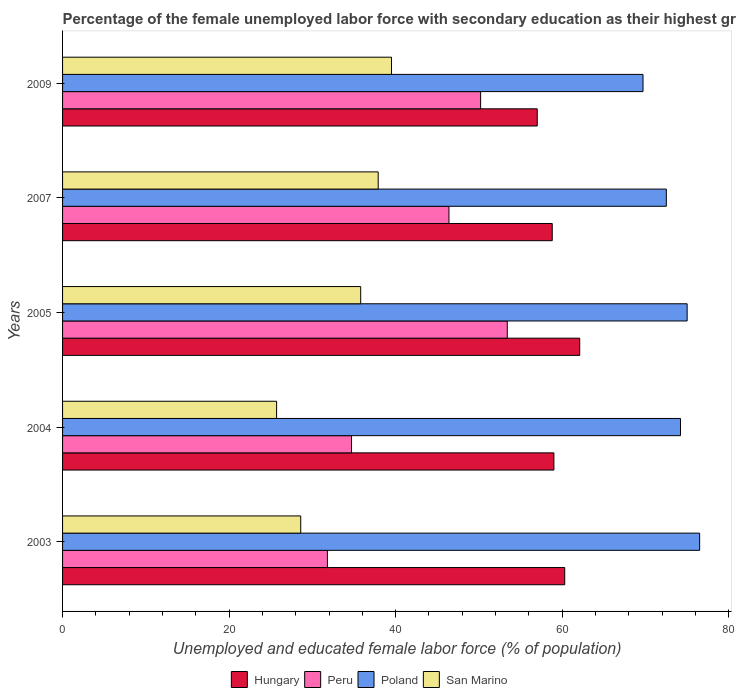How many bars are there on the 1st tick from the bottom?
Offer a terse response. 4. In how many cases, is the number of bars for a given year not equal to the number of legend labels?
Make the answer very short. 0. What is the percentage of the unemployed female labor force with secondary education in Poland in 2009?
Give a very brief answer. 69.7. Across all years, what is the maximum percentage of the unemployed female labor force with secondary education in Peru?
Provide a short and direct response. 53.4. Across all years, what is the minimum percentage of the unemployed female labor force with secondary education in Poland?
Give a very brief answer. 69.7. What is the total percentage of the unemployed female labor force with secondary education in San Marino in the graph?
Ensure brevity in your answer.  167.5. What is the difference between the percentage of the unemployed female labor force with secondary education in Poland in 2004 and that in 2005?
Offer a very short reply. -0.8. What is the difference between the percentage of the unemployed female labor force with secondary education in San Marino in 2004 and the percentage of the unemployed female labor force with secondary education in Peru in 2005?
Keep it short and to the point. -27.7. What is the average percentage of the unemployed female labor force with secondary education in Peru per year?
Your response must be concise. 43.3. In the year 2003, what is the difference between the percentage of the unemployed female labor force with secondary education in Hungary and percentage of the unemployed female labor force with secondary education in San Marino?
Your response must be concise. 31.7. What is the ratio of the percentage of the unemployed female labor force with secondary education in Poland in 2007 to that in 2009?
Provide a succinct answer. 1.04. Is the difference between the percentage of the unemployed female labor force with secondary education in Hungary in 2003 and 2007 greater than the difference between the percentage of the unemployed female labor force with secondary education in San Marino in 2003 and 2007?
Give a very brief answer. Yes. What is the difference between the highest and the second highest percentage of the unemployed female labor force with secondary education in Poland?
Offer a very short reply. 1.5. What is the difference between the highest and the lowest percentage of the unemployed female labor force with secondary education in Peru?
Give a very brief answer. 21.6. In how many years, is the percentage of the unemployed female labor force with secondary education in Poland greater than the average percentage of the unemployed female labor force with secondary education in Poland taken over all years?
Keep it short and to the point. 3. Is it the case that in every year, the sum of the percentage of the unemployed female labor force with secondary education in Peru and percentage of the unemployed female labor force with secondary education in San Marino is greater than the sum of percentage of the unemployed female labor force with secondary education in Poland and percentage of the unemployed female labor force with secondary education in Hungary?
Provide a succinct answer. No. What does the 4th bar from the top in 2007 represents?
Keep it short and to the point. Hungary. Is it the case that in every year, the sum of the percentage of the unemployed female labor force with secondary education in Peru and percentage of the unemployed female labor force with secondary education in San Marino is greater than the percentage of the unemployed female labor force with secondary education in Hungary?
Offer a terse response. Yes. How many bars are there?
Offer a terse response. 20. What is the difference between two consecutive major ticks on the X-axis?
Provide a succinct answer. 20. Does the graph contain grids?
Your answer should be very brief. No. How many legend labels are there?
Make the answer very short. 4. What is the title of the graph?
Your answer should be compact. Percentage of the female unemployed labor force with secondary education as their highest grade. Does "Tunisia" appear as one of the legend labels in the graph?
Keep it short and to the point. No. What is the label or title of the X-axis?
Make the answer very short. Unemployed and educated female labor force (% of population). What is the label or title of the Y-axis?
Give a very brief answer. Years. What is the Unemployed and educated female labor force (% of population) of Hungary in 2003?
Offer a terse response. 60.3. What is the Unemployed and educated female labor force (% of population) in Peru in 2003?
Your response must be concise. 31.8. What is the Unemployed and educated female labor force (% of population) in Poland in 2003?
Give a very brief answer. 76.5. What is the Unemployed and educated female labor force (% of population) of San Marino in 2003?
Offer a very short reply. 28.6. What is the Unemployed and educated female labor force (% of population) of Peru in 2004?
Offer a terse response. 34.7. What is the Unemployed and educated female labor force (% of population) of Poland in 2004?
Your answer should be compact. 74.2. What is the Unemployed and educated female labor force (% of population) in San Marino in 2004?
Offer a very short reply. 25.7. What is the Unemployed and educated female labor force (% of population) of Hungary in 2005?
Your answer should be compact. 62.1. What is the Unemployed and educated female labor force (% of population) in Peru in 2005?
Your answer should be compact. 53.4. What is the Unemployed and educated female labor force (% of population) in Poland in 2005?
Your response must be concise. 75. What is the Unemployed and educated female labor force (% of population) in San Marino in 2005?
Offer a terse response. 35.8. What is the Unemployed and educated female labor force (% of population) of Hungary in 2007?
Offer a very short reply. 58.8. What is the Unemployed and educated female labor force (% of population) of Peru in 2007?
Offer a very short reply. 46.4. What is the Unemployed and educated female labor force (% of population) of Poland in 2007?
Give a very brief answer. 72.5. What is the Unemployed and educated female labor force (% of population) in San Marino in 2007?
Give a very brief answer. 37.9. What is the Unemployed and educated female labor force (% of population) of Hungary in 2009?
Keep it short and to the point. 57. What is the Unemployed and educated female labor force (% of population) of Peru in 2009?
Ensure brevity in your answer.  50.2. What is the Unemployed and educated female labor force (% of population) in Poland in 2009?
Give a very brief answer. 69.7. What is the Unemployed and educated female labor force (% of population) of San Marino in 2009?
Your answer should be very brief. 39.5. Across all years, what is the maximum Unemployed and educated female labor force (% of population) in Hungary?
Your answer should be compact. 62.1. Across all years, what is the maximum Unemployed and educated female labor force (% of population) of Peru?
Your response must be concise. 53.4. Across all years, what is the maximum Unemployed and educated female labor force (% of population) of Poland?
Give a very brief answer. 76.5. Across all years, what is the maximum Unemployed and educated female labor force (% of population) in San Marino?
Offer a very short reply. 39.5. Across all years, what is the minimum Unemployed and educated female labor force (% of population) in Hungary?
Make the answer very short. 57. Across all years, what is the minimum Unemployed and educated female labor force (% of population) in Peru?
Offer a terse response. 31.8. Across all years, what is the minimum Unemployed and educated female labor force (% of population) of Poland?
Provide a succinct answer. 69.7. Across all years, what is the minimum Unemployed and educated female labor force (% of population) in San Marino?
Provide a short and direct response. 25.7. What is the total Unemployed and educated female labor force (% of population) of Hungary in the graph?
Your response must be concise. 297.2. What is the total Unemployed and educated female labor force (% of population) in Peru in the graph?
Your answer should be compact. 216.5. What is the total Unemployed and educated female labor force (% of population) of Poland in the graph?
Your answer should be very brief. 367.9. What is the total Unemployed and educated female labor force (% of population) of San Marino in the graph?
Your answer should be compact. 167.5. What is the difference between the Unemployed and educated female labor force (% of population) of San Marino in 2003 and that in 2004?
Your answer should be very brief. 2.9. What is the difference between the Unemployed and educated female labor force (% of population) of Peru in 2003 and that in 2005?
Keep it short and to the point. -21.6. What is the difference between the Unemployed and educated female labor force (% of population) of San Marino in 2003 and that in 2005?
Make the answer very short. -7.2. What is the difference between the Unemployed and educated female labor force (% of population) in Hungary in 2003 and that in 2007?
Offer a very short reply. 1.5. What is the difference between the Unemployed and educated female labor force (% of population) of Peru in 2003 and that in 2007?
Your answer should be very brief. -14.6. What is the difference between the Unemployed and educated female labor force (% of population) in Poland in 2003 and that in 2007?
Your answer should be compact. 4. What is the difference between the Unemployed and educated female labor force (% of population) in San Marino in 2003 and that in 2007?
Give a very brief answer. -9.3. What is the difference between the Unemployed and educated female labor force (% of population) of Hungary in 2003 and that in 2009?
Make the answer very short. 3.3. What is the difference between the Unemployed and educated female labor force (% of population) in Peru in 2003 and that in 2009?
Your answer should be very brief. -18.4. What is the difference between the Unemployed and educated female labor force (% of population) in Poland in 2003 and that in 2009?
Keep it short and to the point. 6.8. What is the difference between the Unemployed and educated female labor force (% of population) of San Marino in 2003 and that in 2009?
Give a very brief answer. -10.9. What is the difference between the Unemployed and educated female labor force (% of population) of Hungary in 2004 and that in 2005?
Give a very brief answer. -3.1. What is the difference between the Unemployed and educated female labor force (% of population) in Peru in 2004 and that in 2005?
Your answer should be very brief. -18.7. What is the difference between the Unemployed and educated female labor force (% of population) in Peru in 2004 and that in 2007?
Give a very brief answer. -11.7. What is the difference between the Unemployed and educated female labor force (% of population) of Peru in 2004 and that in 2009?
Give a very brief answer. -15.5. What is the difference between the Unemployed and educated female labor force (% of population) in Poland in 2004 and that in 2009?
Ensure brevity in your answer.  4.5. What is the difference between the Unemployed and educated female labor force (% of population) in Peru in 2005 and that in 2007?
Keep it short and to the point. 7. What is the difference between the Unemployed and educated female labor force (% of population) of Peru in 2005 and that in 2009?
Your answer should be compact. 3.2. What is the difference between the Unemployed and educated female labor force (% of population) of Poland in 2005 and that in 2009?
Your response must be concise. 5.3. What is the difference between the Unemployed and educated female labor force (% of population) of San Marino in 2005 and that in 2009?
Offer a very short reply. -3.7. What is the difference between the Unemployed and educated female labor force (% of population) of Poland in 2007 and that in 2009?
Provide a short and direct response. 2.8. What is the difference between the Unemployed and educated female labor force (% of population) in Hungary in 2003 and the Unemployed and educated female labor force (% of population) in Peru in 2004?
Keep it short and to the point. 25.6. What is the difference between the Unemployed and educated female labor force (% of population) in Hungary in 2003 and the Unemployed and educated female labor force (% of population) in San Marino in 2004?
Ensure brevity in your answer.  34.6. What is the difference between the Unemployed and educated female labor force (% of population) in Peru in 2003 and the Unemployed and educated female labor force (% of population) in Poland in 2004?
Ensure brevity in your answer.  -42.4. What is the difference between the Unemployed and educated female labor force (% of population) of Poland in 2003 and the Unemployed and educated female labor force (% of population) of San Marino in 2004?
Your answer should be very brief. 50.8. What is the difference between the Unemployed and educated female labor force (% of population) of Hungary in 2003 and the Unemployed and educated female labor force (% of population) of Peru in 2005?
Offer a terse response. 6.9. What is the difference between the Unemployed and educated female labor force (% of population) of Hungary in 2003 and the Unemployed and educated female labor force (% of population) of Poland in 2005?
Give a very brief answer. -14.7. What is the difference between the Unemployed and educated female labor force (% of population) of Hungary in 2003 and the Unemployed and educated female labor force (% of population) of San Marino in 2005?
Give a very brief answer. 24.5. What is the difference between the Unemployed and educated female labor force (% of population) of Peru in 2003 and the Unemployed and educated female labor force (% of population) of Poland in 2005?
Give a very brief answer. -43.2. What is the difference between the Unemployed and educated female labor force (% of population) in Peru in 2003 and the Unemployed and educated female labor force (% of population) in San Marino in 2005?
Keep it short and to the point. -4. What is the difference between the Unemployed and educated female labor force (% of population) of Poland in 2003 and the Unemployed and educated female labor force (% of population) of San Marino in 2005?
Ensure brevity in your answer.  40.7. What is the difference between the Unemployed and educated female labor force (% of population) of Hungary in 2003 and the Unemployed and educated female labor force (% of population) of San Marino in 2007?
Your answer should be compact. 22.4. What is the difference between the Unemployed and educated female labor force (% of population) in Peru in 2003 and the Unemployed and educated female labor force (% of population) in Poland in 2007?
Your answer should be very brief. -40.7. What is the difference between the Unemployed and educated female labor force (% of population) of Poland in 2003 and the Unemployed and educated female labor force (% of population) of San Marino in 2007?
Give a very brief answer. 38.6. What is the difference between the Unemployed and educated female labor force (% of population) of Hungary in 2003 and the Unemployed and educated female labor force (% of population) of Poland in 2009?
Give a very brief answer. -9.4. What is the difference between the Unemployed and educated female labor force (% of population) of Hungary in 2003 and the Unemployed and educated female labor force (% of population) of San Marino in 2009?
Your response must be concise. 20.8. What is the difference between the Unemployed and educated female labor force (% of population) of Peru in 2003 and the Unemployed and educated female labor force (% of population) of Poland in 2009?
Your answer should be compact. -37.9. What is the difference between the Unemployed and educated female labor force (% of population) in Poland in 2003 and the Unemployed and educated female labor force (% of population) in San Marino in 2009?
Provide a succinct answer. 37. What is the difference between the Unemployed and educated female labor force (% of population) in Hungary in 2004 and the Unemployed and educated female labor force (% of population) in San Marino in 2005?
Make the answer very short. 23.2. What is the difference between the Unemployed and educated female labor force (% of population) of Peru in 2004 and the Unemployed and educated female labor force (% of population) of Poland in 2005?
Your answer should be very brief. -40.3. What is the difference between the Unemployed and educated female labor force (% of population) in Peru in 2004 and the Unemployed and educated female labor force (% of population) in San Marino in 2005?
Your response must be concise. -1.1. What is the difference between the Unemployed and educated female labor force (% of population) of Poland in 2004 and the Unemployed and educated female labor force (% of population) of San Marino in 2005?
Provide a succinct answer. 38.4. What is the difference between the Unemployed and educated female labor force (% of population) in Hungary in 2004 and the Unemployed and educated female labor force (% of population) in San Marino in 2007?
Your answer should be very brief. 21.1. What is the difference between the Unemployed and educated female labor force (% of population) in Peru in 2004 and the Unemployed and educated female labor force (% of population) in Poland in 2007?
Your answer should be compact. -37.8. What is the difference between the Unemployed and educated female labor force (% of population) in Poland in 2004 and the Unemployed and educated female labor force (% of population) in San Marino in 2007?
Give a very brief answer. 36.3. What is the difference between the Unemployed and educated female labor force (% of population) in Hungary in 2004 and the Unemployed and educated female labor force (% of population) in Peru in 2009?
Provide a short and direct response. 8.8. What is the difference between the Unemployed and educated female labor force (% of population) in Hungary in 2004 and the Unemployed and educated female labor force (% of population) in Poland in 2009?
Your answer should be very brief. -10.7. What is the difference between the Unemployed and educated female labor force (% of population) in Peru in 2004 and the Unemployed and educated female labor force (% of population) in Poland in 2009?
Make the answer very short. -35. What is the difference between the Unemployed and educated female labor force (% of population) in Peru in 2004 and the Unemployed and educated female labor force (% of population) in San Marino in 2009?
Your response must be concise. -4.8. What is the difference between the Unemployed and educated female labor force (% of population) of Poland in 2004 and the Unemployed and educated female labor force (% of population) of San Marino in 2009?
Keep it short and to the point. 34.7. What is the difference between the Unemployed and educated female labor force (% of population) of Hungary in 2005 and the Unemployed and educated female labor force (% of population) of Poland in 2007?
Keep it short and to the point. -10.4. What is the difference between the Unemployed and educated female labor force (% of population) in Hungary in 2005 and the Unemployed and educated female labor force (% of population) in San Marino in 2007?
Make the answer very short. 24.2. What is the difference between the Unemployed and educated female labor force (% of population) of Peru in 2005 and the Unemployed and educated female labor force (% of population) of Poland in 2007?
Your answer should be compact. -19.1. What is the difference between the Unemployed and educated female labor force (% of population) of Peru in 2005 and the Unemployed and educated female labor force (% of population) of San Marino in 2007?
Ensure brevity in your answer.  15.5. What is the difference between the Unemployed and educated female labor force (% of population) in Poland in 2005 and the Unemployed and educated female labor force (% of population) in San Marino in 2007?
Your response must be concise. 37.1. What is the difference between the Unemployed and educated female labor force (% of population) in Hungary in 2005 and the Unemployed and educated female labor force (% of population) in Peru in 2009?
Provide a short and direct response. 11.9. What is the difference between the Unemployed and educated female labor force (% of population) of Hungary in 2005 and the Unemployed and educated female labor force (% of population) of San Marino in 2009?
Your answer should be very brief. 22.6. What is the difference between the Unemployed and educated female labor force (% of population) in Peru in 2005 and the Unemployed and educated female labor force (% of population) in Poland in 2009?
Make the answer very short. -16.3. What is the difference between the Unemployed and educated female labor force (% of population) in Peru in 2005 and the Unemployed and educated female labor force (% of population) in San Marino in 2009?
Make the answer very short. 13.9. What is the difference between the Unemployed and educated female labor force (% of population) in Poland in 2005 and the Unemployed and educated female labor force (% of population) in San Marino in 2009?
Provide a short and direct response. 35.5. What is the difference between the Unemployed and educated female labor force (% of population) of Hungary in 2007 and the Unemployed and educated female labor force (% of population) of Poland in 2009?
Keep it short and to the point. -10.9. What is the difference between the Unemployed and educated female labor force (% of population) of Hungary in 2007 and the Unemployed and educated female labor force (% of population) of San Marino in 2009?
Give a very brief answer. 19.3. What is the difference between the Unemployed and educated female labor force (% of population) of Peru in 2007 and the Unemployed and educated female labor force (% of population) of Poland in 2009?
Provide a succinct answer. -23.3. What is the difference between the Unemployed and educated female labor force (% of population) of Peru in 2007 and the Unemployed and educated female labor force (% of population) of San Marino in 2009?
Your response must be concise. 6.9. What is the average Unemployed and educated female labor force (% of population) in Hungary per year?
Give a very brief answer. 59.44. What is the average Unemployed and educated female labor force (% of population) of Peru per year?
Ensure brevity in your answer.  43.3. What is the average Unemployed and educated female labor force (% of population) of Poland per year?
Offer a terse response. 73.58. What is the average Unemployed and educated female labor force (% of population) in San Marino per year?
Ensure brevity in your answer.  33.5. In the year 2003, what is the difference between the Unemployed and educated female labor force (% of population) of Hungary and Unemployed and educated female labor force (% of population) of Peru?
Provide a succinct answer. 28.5. In the year 2003, what is the difference between the Unemployed and educated female labor force (% of population) of Hungary and Unemployed and educated female labor force (% of population) of Poland?
Ensure brevity in your answer.  -16.2. In the year 2003, what is the difference between the Unemployed and educated female labor force (% of population) of Hungary and Unemployed and educated female labor force (% of population) of San Marino?
Your answer should be compact. 31.7. In the year 2003, what is the difference between the Unemployed and educated female labor force (% of population) in Peru and Unemployed and educated female labor force (% of population) in Poland?
Make the answer very short. -44.7. In the year 2003, what is the difference between the Unemployed and educated female labor force (% of population) in Peru and Unemployed and educated female labor force (% of population) in San Marino?
Your response must be concise. 3.2. In the year 2003, what is the difference between the Unemployed and educated female labor force (% of population) of Poland and Unemployed and educated female labor force (% of population) of San Marino?
Offer a terse response. 47.9. In the year 2004, what is the difference between the Unemployed and educated female labor force (% of population) in Hungary and Unemployed and educated female labor force (% of population) in Peru?
Provide a short and direct response. 24.3. In the year 2004, what is the difference between the Unemployed and educated female labor force (% of population) in Hungary and Unemployed and educated female labor force (% of population) in Poland?
Offer a terse response. -15.2. In the year 2004, what is the difference between the Unemployed and educated female labor force (% of population) in Hungary and Unemployed and educated female labor force (% of population) in San Marino?
Provide a succinct answer. 33.3. In the year 2004, what is the difference between the Unemployed and educated female labor force (% of population) of Peru and Unemployed and educated female labor force (% of population) of Poland?
Provide a short and direct response. -39.5. In the year 2004, what is the difference between the Unemployed and educated female labor force (% of population) in Poland and Unemployed and educated female labor force (% of population) in San Marino?
Provide a short and direct response. 48.5. In the year 2005, what is the difference between the Unemployed and educated female labor force (% of population) of Hungary and Unemployed and educated female labor force (% of population) of Peru?
Your answer should be compact. 8.7. In the year 2005, what is the difference between the Unemployed and educated female labor force (% of population) of Hungary and Unemployed and educated female labor force (% of population) of San Marino?
Keep it short and to the point. 26.3. In the year 2005, what is the difference between the Unemployed and educated female labor force (% of population) of Peru and Unemployed and educated female labor force (% of population) of Poland?
Keep it short and to the point. -21.6. In the year 2005, what is the difference between the Unemployed and educated female labor force (% of population) of Poland and Unemployed and educated female labor force (% of population) of San Marino?
Keep it short and to the point. 39.2. In the year 2007, what is the difference between the Unemployed and educated female labor force (% of population) of Hungary and Unemployed and educated female labor force (% of population) of Poland?
Ensure brevity in your answer.  -13.7. In the year 2007, what is the difference between the Unemployed and educated female labor force (% of population) in Hungary and Unemployed and educated female labor force (% of population) in San Marino?
Provide a succinct answer. 20.9. In the year 2007, what is the difference between the Unemployed and educated female labor force (% of population) in Peru and Unemployed and educated female labor force (% of population) in Poland?
Your response must be concise. -26.1. In the year 2007, what is the difference between the Unemployed and educated female labor force (% of population) of Poland and Unemployed and educated female labor force (% of population) of San Marino?
Keep it short and to the point. 34.6. In the year 2009, what is the difference between the Unemployed and educated female labor force (% of population) in Peru and Unemployed and educated female labor force (% of population) in Poland?
Your answer should be compact. -19.5. In the year 2009, what is the difference between the Unemployed and educated female labor force (% of population) of Peru and Unemployed and educated female labor force (% of population) of San Marino?
Offer a terse response. 10.7. In the year 2009, what is the difference between the Unemployed and educated female labor force (% of population) in Poland and Unemployed and educated female labor force (% of population) in San Marino?
Keep it short and to the point. 30.2. What is the ratio of the Unemployed and educated female labor force (% of population) in Hungary in 2003 to that in 2004?
Make the answer very short. 1.02. What is the ratio of the Unemployed and educated female labor force (% of population) in Peru in 2003 to that in 2004?
Ensure brevity in your answer.  0.92. What is the ratio of the Unemployed and educated female labor force (% of population) in Poland in 2003 to that in 2004?
Your answer should be very brief. 1.03. What is the ratio of the Unemployed and educated female labor force (% of population) in San Marino in 2003 to that in 2004?
Your answer should be compact. 1.11. What is the ratio of the Unemployed and educated female labor force (% of population) of Peru in 2003 to that in 2005?
Keep it short and to the point. 0.6. What is the ratio of the Unemployed and educated female labor force (% of population) of San Marino in 2003 to that in 2005?
Offer a very short reply. 0.8. What is the ratio of the Unemployed and educated female labor force (% of population) in Hungary in 2003 to that in 2007?
Give a very brief answer. 1.03. What is the ratio of the Unemployed and educated female labor force (% of population) in Peru in 2003 to that in 2007?
Give a very brief answer. 0.69. What is the ratio of the Unemployed and educated female labor force (% of population) of Poland in 2003 to that in 2007?
Your response must be concise. 1.06. What is the ratio of the Unemployed and educated female labor force (% of population) in San Marino in 2003 to that in 2007?
Ensure brevity in your answer.  0.75. What is the ratio of the Unemployed and educated female labor force (% of population) in Hungary in 2003 to that in 2009?
Offer a very short reply. 1.06. What is the ratio of the Unemployed and educated female labor force (% of population) in Peru in 2003 to that in 2009?
Keep it short and to the point. 0.63. What is the ratio of the Unemployed and educated female labor force (% of population) of Poland in 2003 to that in 2009?
Your answer should be very brief. 1.1. What is the ratio of the Unemployed and educated female labor force (% of population) of San Marino in 2003 to that in 2009?
Ensure brevity in your answer.  0.72. What is the ratio of the Unemployed and educated female labor force (% of population) in Hungary in 2004 to that in 2005?
Ensure brevity in your answer.  0.95. What is the ratio of the Unemployed and educated female labor force (% of population) of Peru in 2004 to that in 2005?
Make the answer very short. 0.65. What is the ratio of the Unemployed and educated female labor force (% of population) in Poland in 2004 to that in 2005?
Provide a succinct answer. 0.99. What is the ratio of the Unemployed and educated female labor force (% of population) in San Marino in 2004 to that in 2005?
Your answer should be very brief. 0.72. What is the ratio of the Unemployed and educated female labor force (% of population) of Peru in 2004 to that in 2007?
Provide a short and direct response. 0.75. What is the ratio of the Unemployed and educated female labor force (% of population) in Poland in 2004 to that in 2007?
Give a very brief answer. 1.02. What is the ratio of the Unemployed and educated female labor force (% of population) in San Marino in 2004 to that in 2007?
Make the answer very short. 0.68. What is the ratio of the Unemployed and educated female labor force (% of population) in Hungary in 2004 to that in 2009?
Provide a succinct answer. 1.04. What is the ratio of the Unemployed and educated female labor force (% of population) in Peru in 2004 to that in 2009?
Provide a succinct answer. 0.69. What is the ratio of the Unemployed and educated female labor force (% of population) in Poland in 2004 to that in 2009?
Offer a terse response. 1.06. What is the ratio of the Unemployed and educated female labor force (% of population) in San Marino in 2004 to that in 2009?
Provide a succinct answer. 0.65. What is the ratio of the Unemployed and educated female labor force (% of population) of Hungary in 2005 to that in 2007?
Offer a terse response. 1.06. What is the ratio of the Unemployed and educated female labor force (% of population) of Peru in 2005 to that in 2007?
Your answer should be compact. 1.15. What is the ratio of the Unemployed and educated female labor force (% of population) of Poland in 2005 to that in 2007?
Your answer should be compact. 1.03. What is the ratio of the Unemployed and educated female labor force (% of population) of San Marino in 2005 to that in 2007?
Your answer should be compact. 0.94. What is the ratio of the Unemployed and educated female labor force (% of population) of Hungary in 2005 to that in 2009?
Your answer should be compact. 1.09. What is the ratio of the Unemployed and educated female labor force (% of population) in Peru in 2005 to that in 2009?
Your answer should be very brief. 1.06. What is the ratio of the Unemployed and educated female labor force (% of population) in Poland in 2005 to that in 2009?
Ensure brevity in your answer.  1.08. What is the ratio of the Unemployed and educated female labor force (% of population) of San Marino in 2005 to that in 2009?
Offer a terse response. 0.91. What is the ratio of the Unemployed and educated female labor force (% of population) in Hungary in 2007 to that in 2009?
Ensure brevity in your answer.  1.03. What is the ratio of the Unemployed and educated female labor force (% of population) of Peru in 2007 to that in 2009?
Give a very brief answer. 0.92. What is the ratio of the Unemployed and educated female labor force (% of population) in Poland in 2007 to that in 2009?
Provide a succinct answer. 1.04. What is the ratio of the Unemployed and educated female labor force (% of population) of San Marino in 2007 to that in 2009?
Your answer should be compact. 0.96. What is the difference between the highest and the second highest Unemployed and educated female labor force (% of population) in Hungary?
Give a very brief answer. 1.8. What is the difference between the highest and the lowest Unemployed and educated female labor force (% of population) of Peru?
Keep it short and to the point. 21.6. What is the difference between the highest and the lowest Unemployed and educated female labor force (% of population) of Poland?
Provide a short and direct response. 6.8. What is the difference between the highest and the lowest Unemployed and educated female labor force (% of population) in San Marino?
Offer a very short reply. 13.8. 